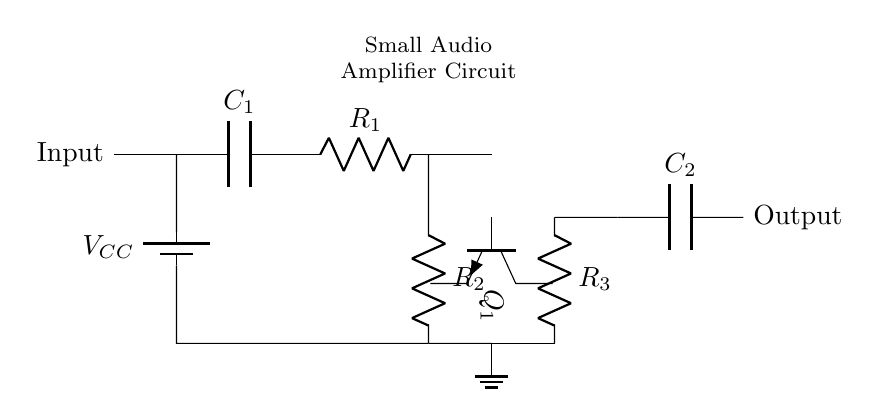What is the component labeled R1? The component labeled R1 represents a resistor in the circuit diagram. Resistors are used to limit current flow and to divide voltage. The label R1 indicates that it is the first resistor in the configuration.
Answer: Resistor What type of transistor is Q1? The component labeled Q1 is an NPN transistor, as indicated by the notation in the circuit. NPN transistors are commonly used for amplification and switching applications.
Answer: NPN How many capacitors are present in the circuit? There are two capacitors present in the circuit, labeled C1 and C2. Capacitors store and release electrical energy, affecting signal timing and filtering.
Answer: Two What is the purpose of R3 in this circuit? R3 acts as a feedback resistor. In amplifier circuits, feedback resistors control the gain and stability of the amplifier, ensuring the output signal does not become distorted.
Answer: Feedback What type of circuit is this? This is a small audio amplifier circuit designed to boost audio signals for portable devices. It is characterized by its use of resistors, capacitors, and a transistor to increase the signal strength.
Answer: Audio amplifier 